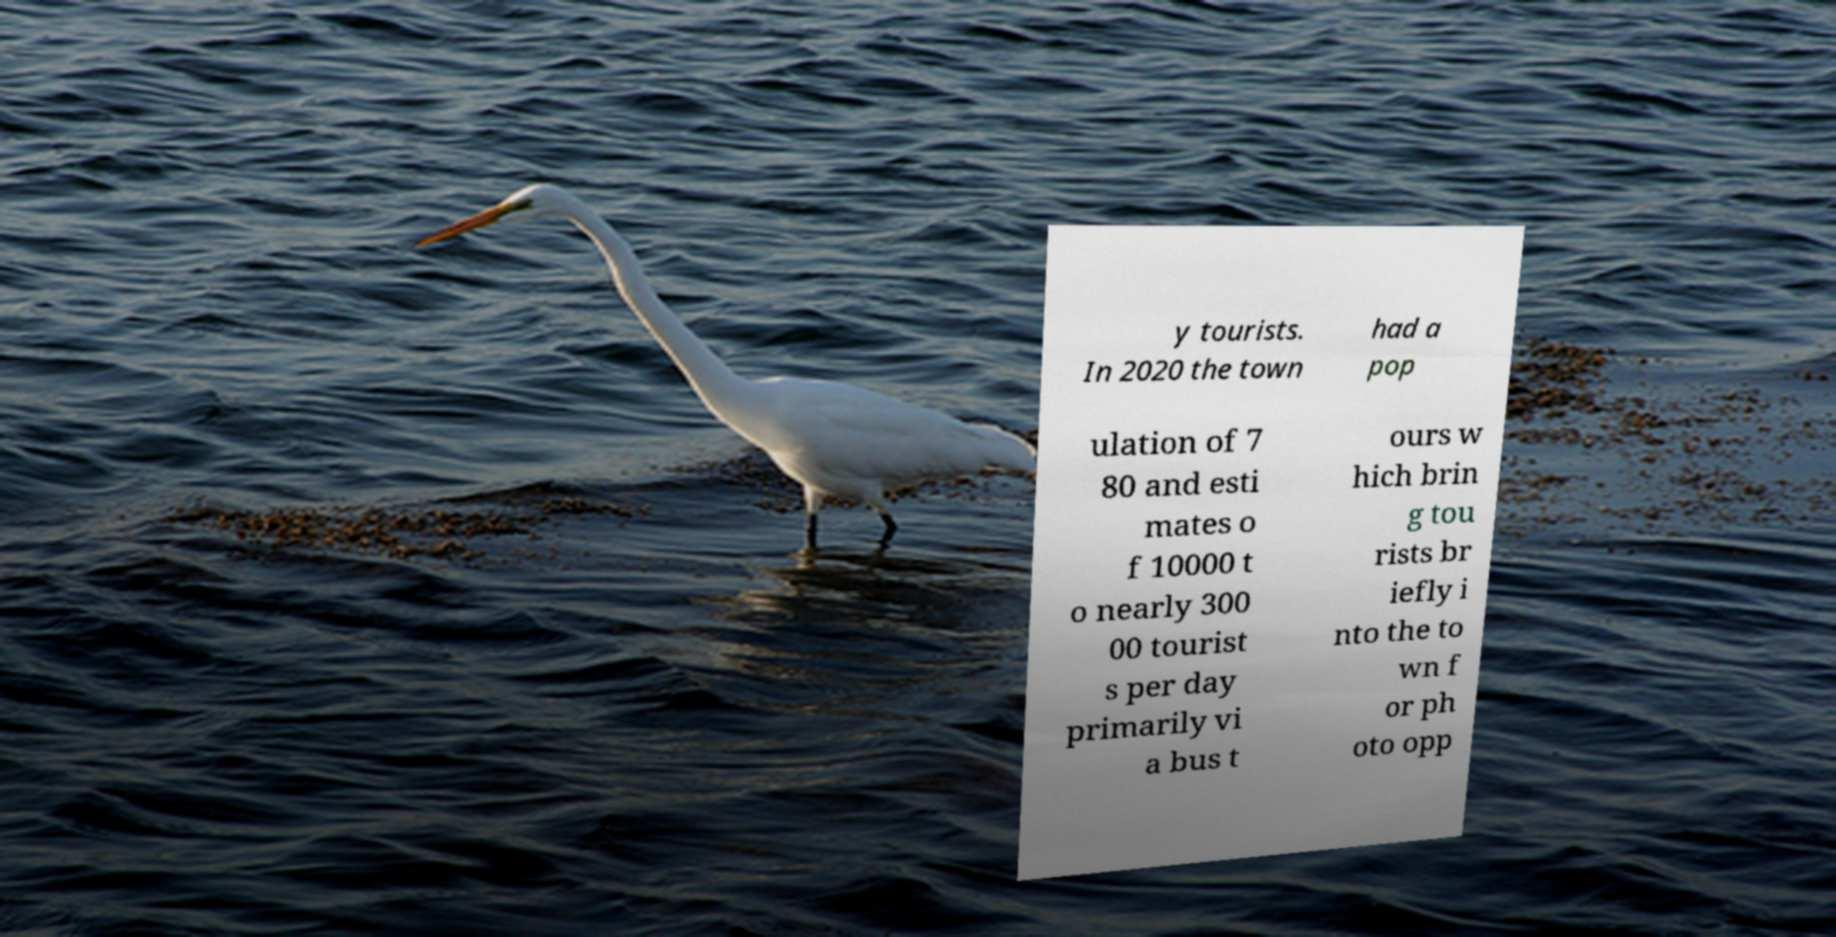Please identify and transcribe the text found in this image. y tourists. In 2020 the town had a pop ulation of 7 80 and esti mates o f 10000 t o nearly 300 00 tourist s per day primarily vi a bus t ours w hich brin g tou rists br iefly i nto the to wn f or ph oto opp 